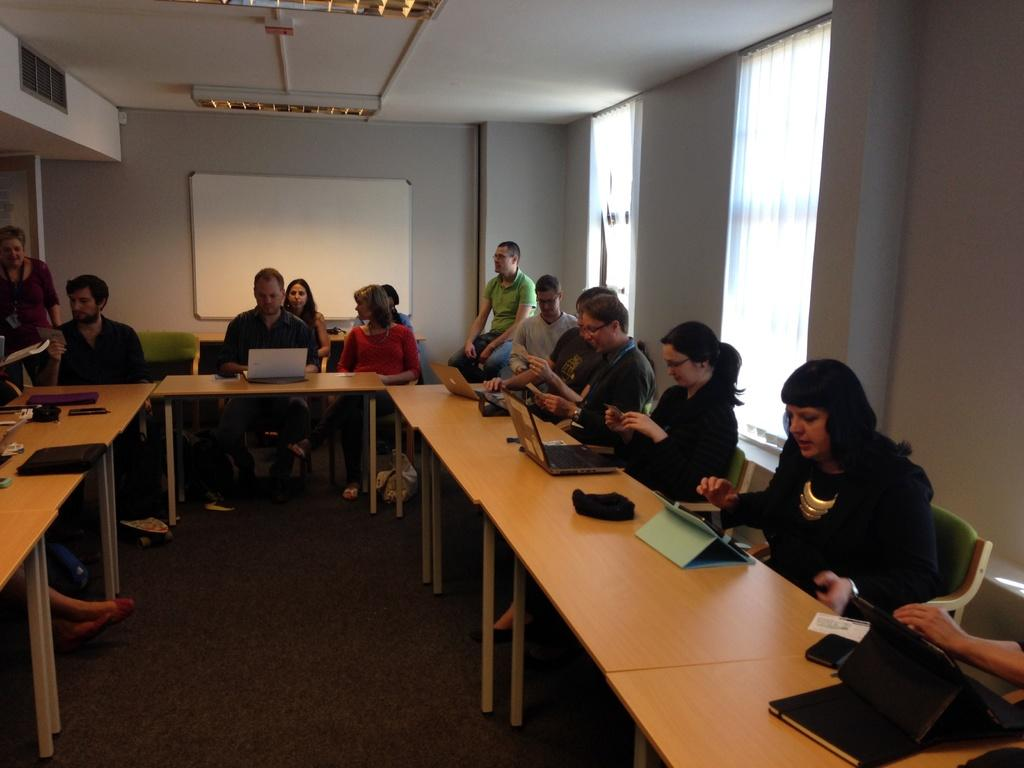How many people are in the image? There is a group of people in the image. What are the people doing in the image? The people are sitting on chairs. What is on the table in front of the people? A laptop is present on the table. What can be seen in the background of the image? There is a wall and a board in the background of the image. What time of day is it in the image, and what are the people talking about? The time of day is not mentioned in the image, and there is no indication of what the people might be talking about. 